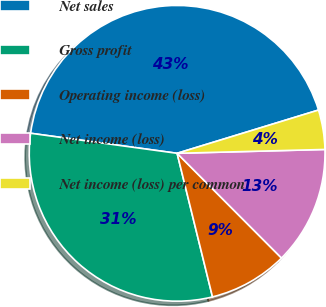<chart> <loc_0><loc_0><loc_500><loc_500><pie_chart><fcel>Net sales<fcel>Gross profit<fcel>Operating income (loss)<fcel>Net income (loss)<fcel>Net income (loss) per common<nl><fcel>43.11%<fcel>31.01%<fcel>8.63%<fcel>12.94%<fcel>4.31%<nl></chart> 